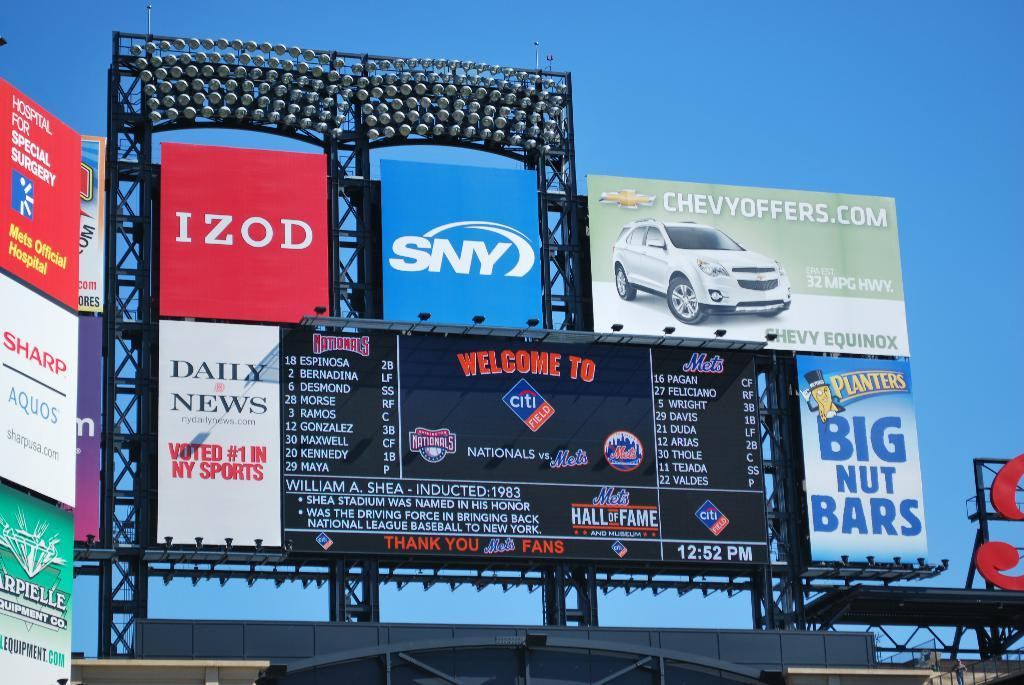<image>
Write a terse but informative summary of the picture. Huge advertising board with Izod, Chevy, SNY and daily news. 